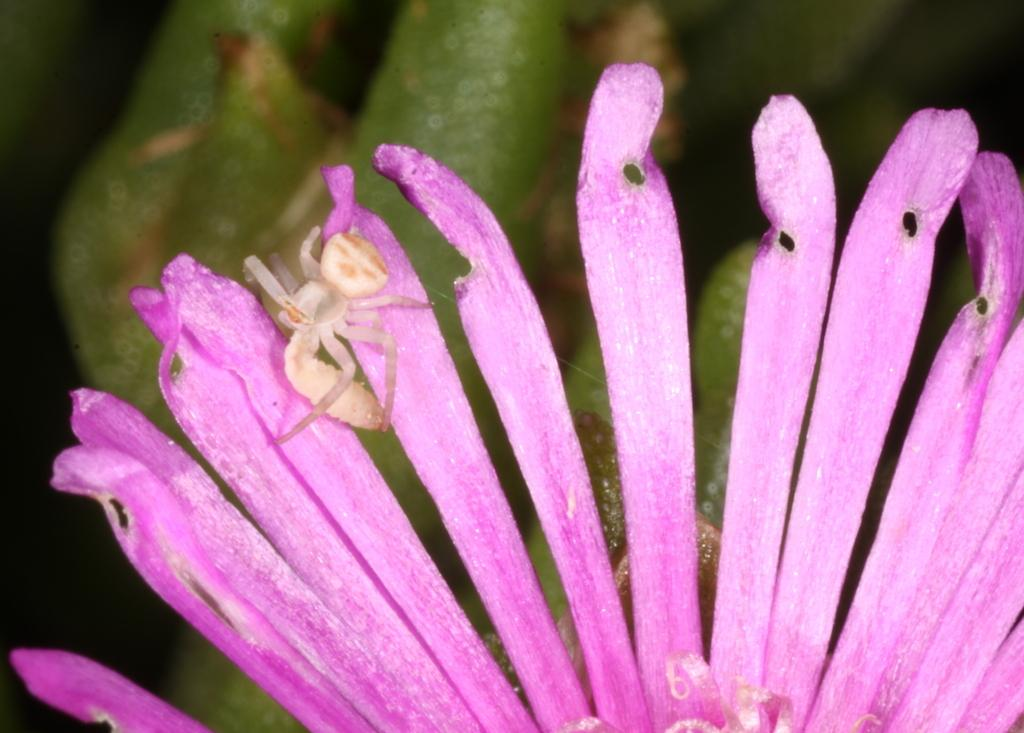What is present on the flower in the image? There is an insect on a flower in the image. What can be seen in the background of the image? There are leaves visible in the background of the image. What reason does the goose have for being in the image? There is no goose present in the image, so it cannot be determined what reason it might have for being there. 